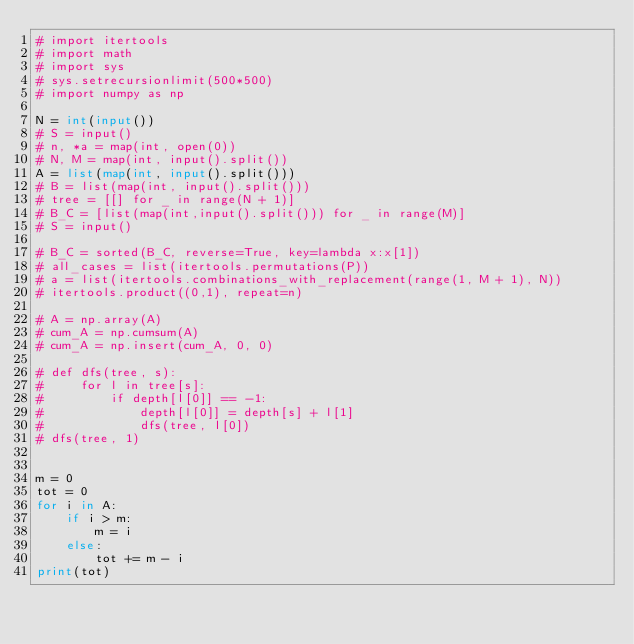Convert code to text. <code><loc_0><loc_0><loc_500><loc_500><_Python_># import itertools
# import math
# import sys
# sys.setrecursionlimit(500*500)
# import numpy as np

N = int(input())
# S = input()
# n, *a = map(int, open(0))
# N, M = map(int, input().split())
A = list(map(int, input().split()))
# B = list(map(int, input().split()))
# tree = [[] for _ in range(N + 1)]
# B_C = [list(map(int,input().split())) for _ in range(M)]
# S = input()

# B_C = sorted(B_C, reverse=True, key=lambda x:x[1])
# all_cases = list(itertools.permutations(P))
# a = list(itertools.combinations_with_replacement(range(1, M + 1), N))
# itertools.product((0,1), repeat=n)

# A = np.array(A)
# cum_A = np.cumsum(A)
# cum_A = np.insert(cum_A, 0, 0)

# def dfs(tree, s):
#     for l in tree[s]:
#         if depth[l[0]] == -1:
#             depth[l[0]] = depth[s] + l[1]
#             dfs(tree, l[0])
# dfs(tree, 1)


m = 0
tot = 0
for i in A:
    if i > m:
        m = i
    else:
        tot += m - i
print(tot)</code> 